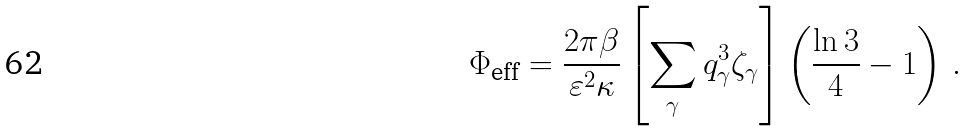Convert formula to latex. <formula><loc_0><loc_0><loc_500><loc_500>\Phi _ { \text {eff} } = \frac { 2 \pi \beta } { \varepsilon ^ { 2 } \kappa } \left [ \sum _ { \gamma } q _ { \gamma } ^ { 3 } \zeta _ { \gamma } \right ] \left ( \frac { \ln 3 } { 4 } - 1 \right ) \, .</formula> 